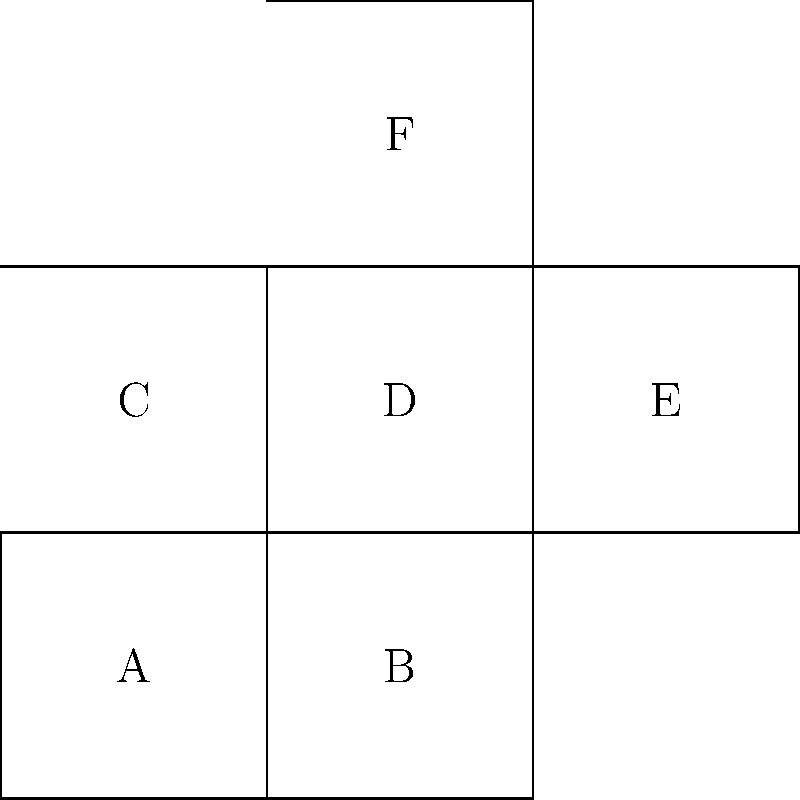As a law student analyzing complex legal structures, you encounter a problem requiring spatial reasoning. Given the 2D net diagram above, which represents the unfolded surface of a 3D shape, identify the correct 3D shape it forms when folded. Additionally, determine which face will be opposite to face A in the folded shape. To solve this problem, we need to follow these steps:

1. Identify the shape:
   - The net consists of 6 equal squares arranged in a cross-like pattern.
   - This arrangement is characteristic of a cube's net.

2. Visualize the folding process:
   - Imagine folding the squares along their edges to form a 3D shape.
   - The four squares around the central square (D) will form the sides of the cube.
   - The top (F) and bottom (B) squares will complete the cube.

3. Determine the opposite face to A:
   - In a cube, opposite faces are those that are parallel and don't share any edges.
   - Face A is on the bottom-left of the net.
   - When folded, face F will be directly opposite to face A.

This spatial reasoning process is analogous to analyzing complex legal structures, where understanding the relationships between different components is crucial. Just as each face of the cube has a specific position relative to the others, legal concepts and precedents have interconnected relationships that must be carefully considered in legal analysis.
Answer: Cube; Face F 